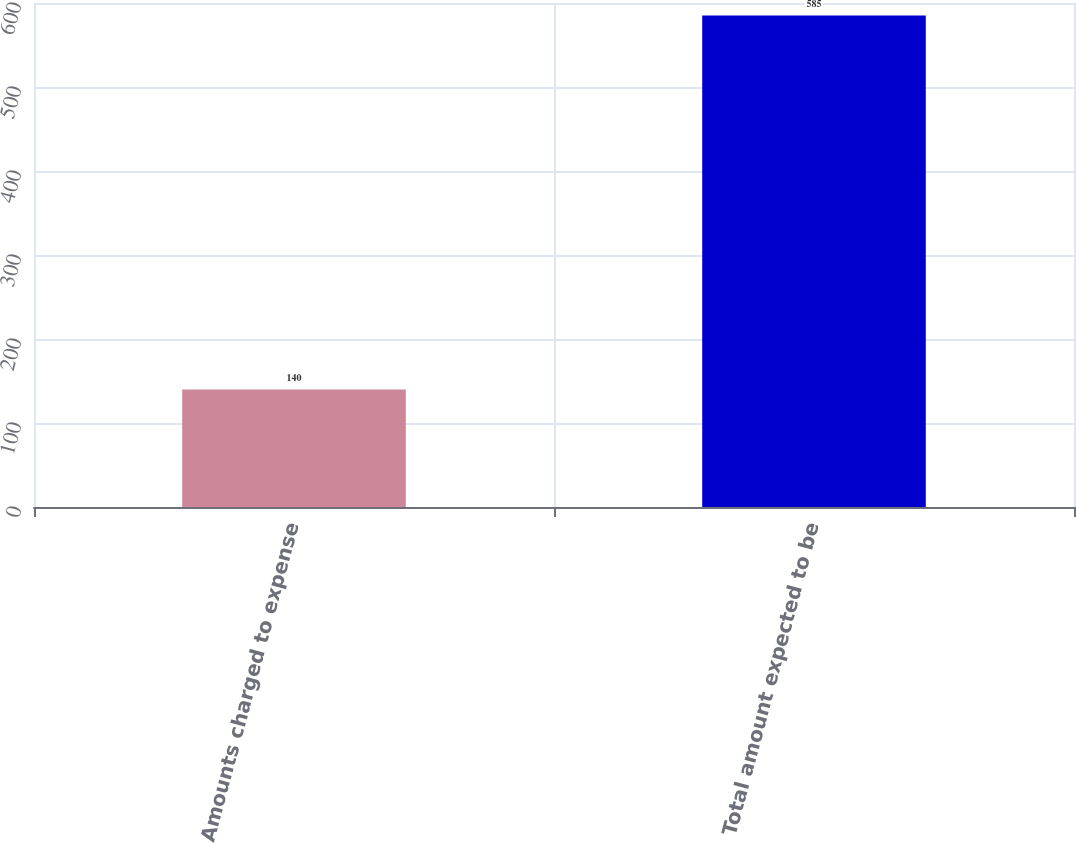Convert chart to OTSL. <chart><loc_0><loc_0><loc_500><loc_500><bar_chart><fcel>Amounts charged to expense<fcel>Total amount expected to be<nl><fcel>140<fcel>585<nl></chart> 